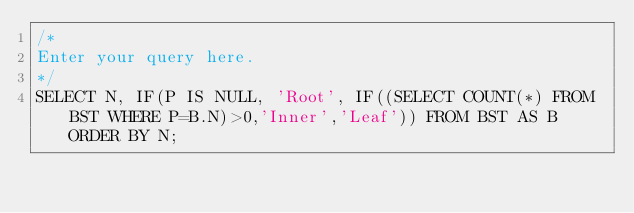Convert code to text. <code><loc_0><loc_0><loc_500><loc_500><_SQL_>/*
Enter your query here.
*/
SELECT N, IF(P IS NULL, 'Root', IF((SELECT COUNT(*) FROM BST WHERE P=B.N)>0,'Inner','Leaf')) FROM BST AS B ORDER BY N;</code> 